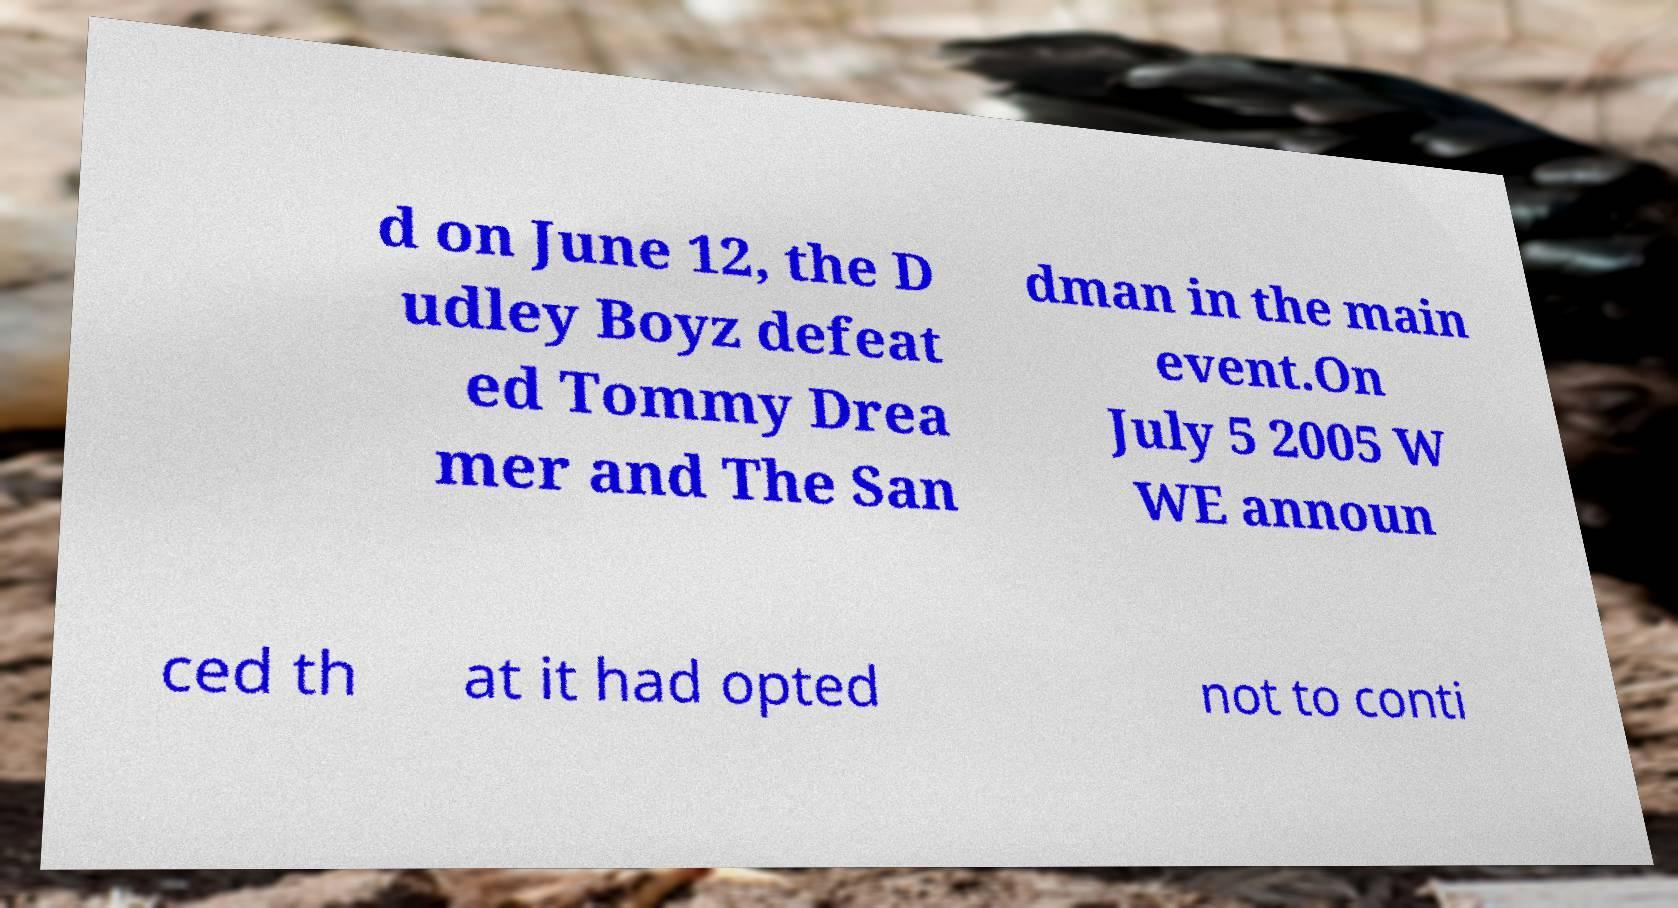There's text embedded in this image that I need extracted. Can you transcribe it verbatim? d on June 12, the D udley Boyz defeat ed Tommy Drea mer and The San dman in the main event.On July 5 2005 W WE announ ced th at it had opted not to conti 